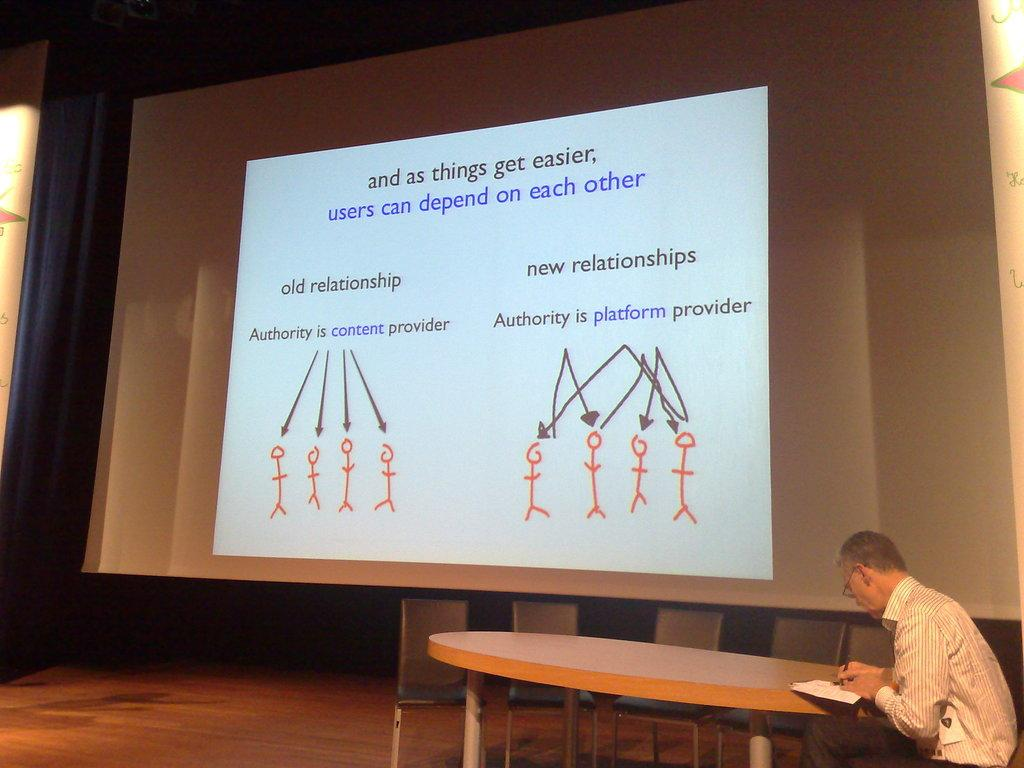Who is present in the image? There is a man in the image. What is the man doing in the image? The man is sitting in a chair. What object is in front of the man? There is a table in front of the man. What is located behind the man? There is a big screen behind the man. What type of cakes are displayed on the table in the image? There is no mention of cakes in the image; the table is not described as having any food items on it. 